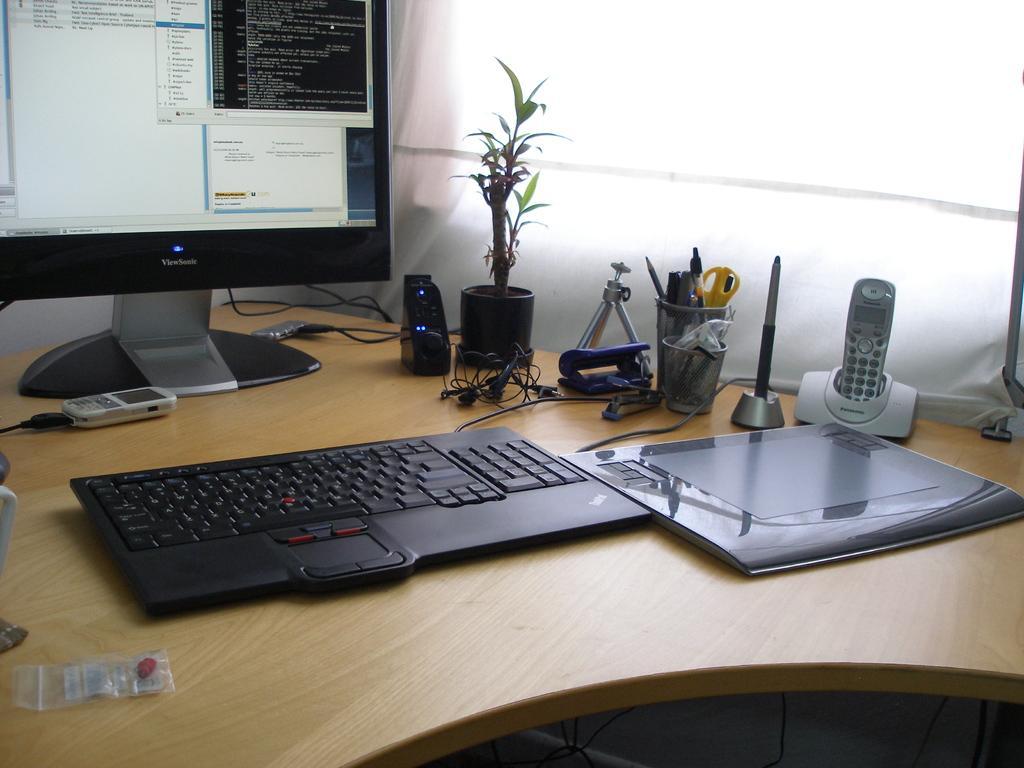Please provide a concise description of this image. There is a table on which a computer was placed along with a files, mobile phones and some accessories on it. In the background there is a window curtain. 